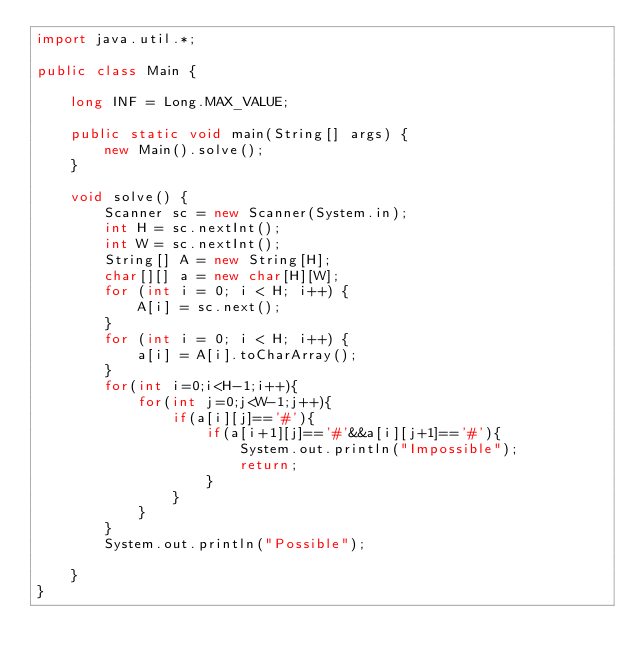Convert code to text. <code><loc_0><loc_0><loc_500><loc_500><_Java_>import java.util.*;

public class Main {

    long INF = Long.MAX_VALUE;

    public static void main(String[] args) {
        new Main().solve();
    }

    void solve() {
        Scanner sc = new Scanner(System.in);
        int H = sc.nextInt();
        int W = sc.nextInt();
        String[] A = new String[H];
        char[][] a = new char[H][W];
        for (int i = 0; i < H; i++) {
            A[i] = sc.next();
        }
        for (int i = 0; i < H; i++) {
            a[i] = A[i].toCharArray();
        }
        for(int i=0;i<H-1;i++){
            for(int j=0;j<W-1;j++){
                if(a[i][j]=='#'){
                    if(a[i+1][j]=='#'&&a[i][j+1]=='#'){
                        System.out.println("Impossible");
                        return;
                    }
                }
            }
        }
        System.out.println("Possible");
        
    }
}</code> 